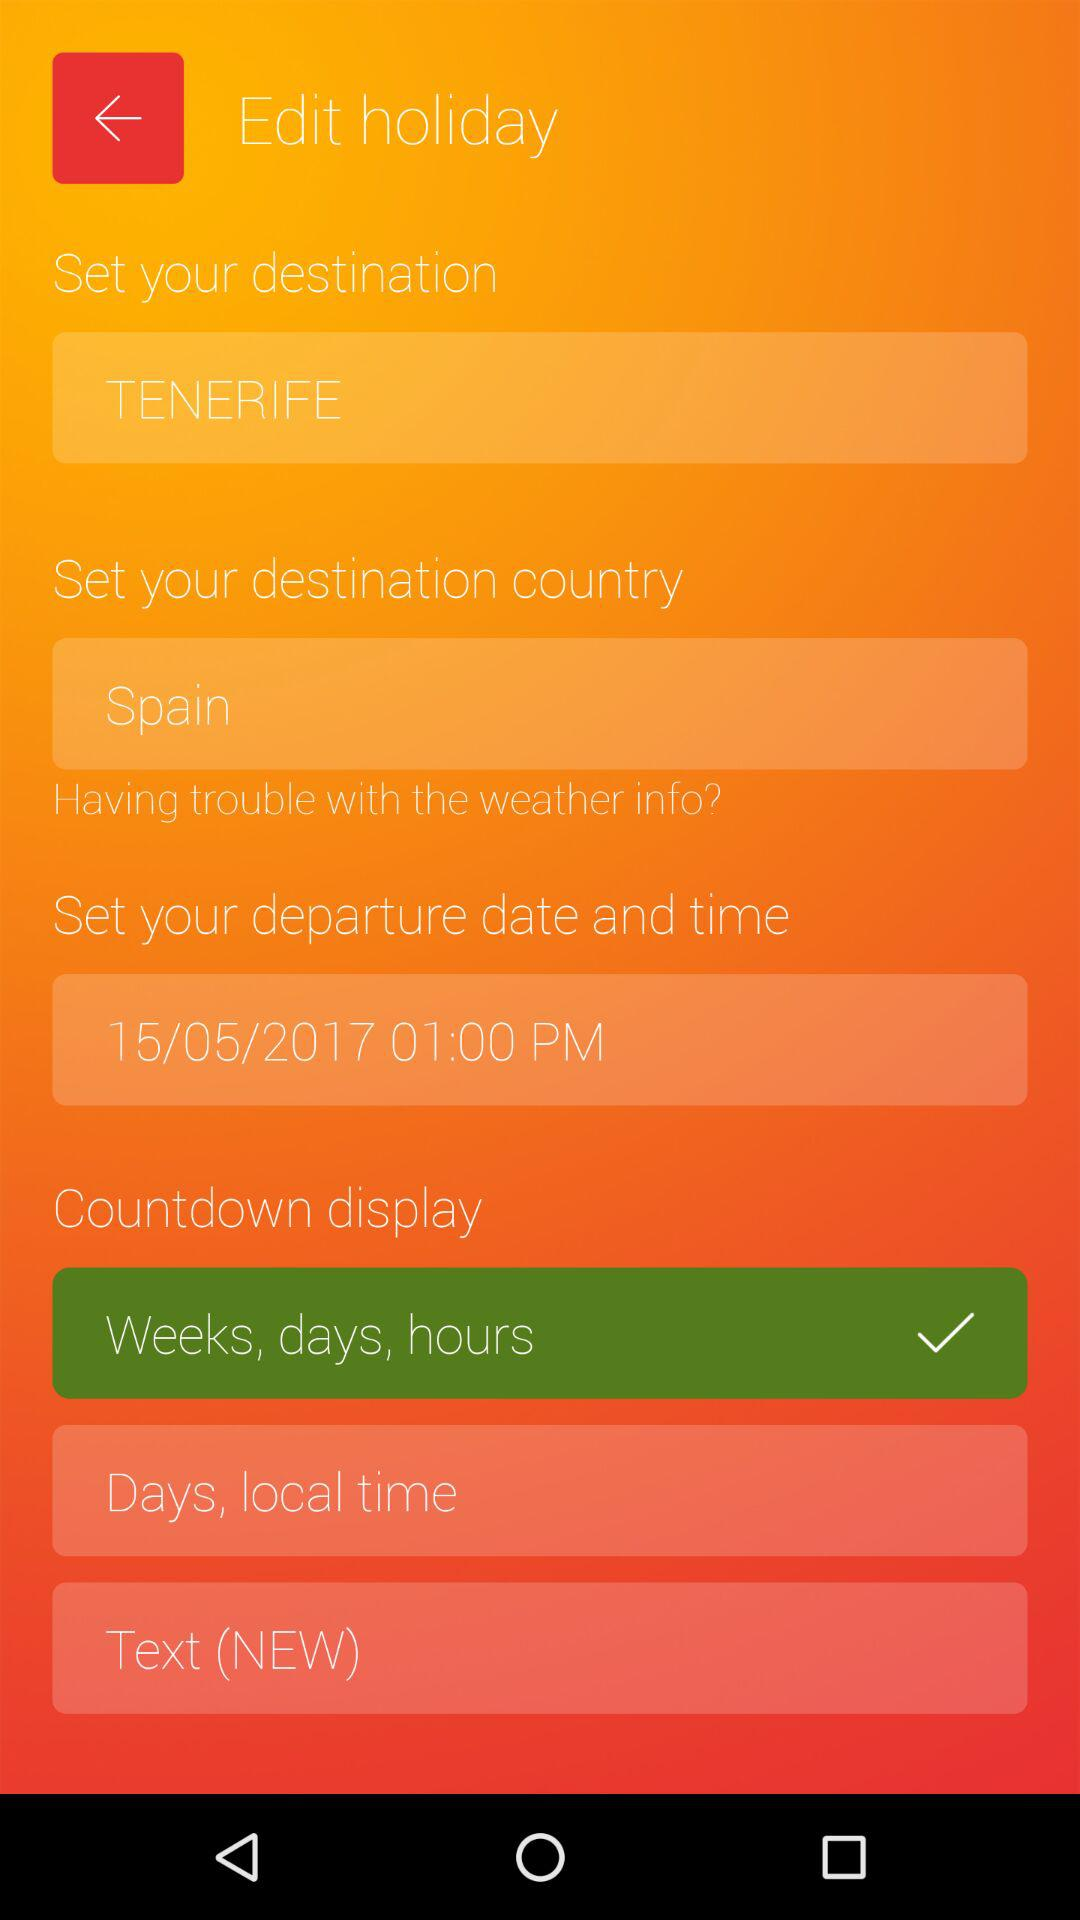What is the selected departure date and time? The departure date and time are May 15, 2017 at 1:00 PM. 